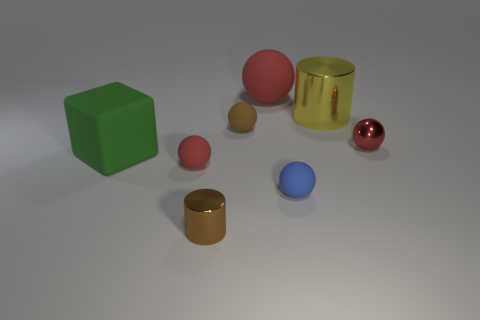Are there fewer red matte things that are on the left side of the small brown matte ball than tiny red rubber balls?
Your answer should be compact. No. There is a large red object that is made of the same material as the green cube; what shape is it?
Offer a very short reply. Sphere. What number of other things are the same shape as the brown matte thing?
Make the answer very short. 4. How many brown things are either metal cylinders or big cylinders?
Ensure brevity in your answer.  1. Is the green object the same shape as the yellow shiny thing?
Your answer should be compact. No. Is there a small metal thing that is in front of the tiny matte object behind the small red metallic ball?
Offer a very short reply. Yes. Are there an equal number of matte things that are in front of the big ball and matte spheres?
Offer a terse response. Yes. How many other objects are there of the same size as the green block?
Provide a short and direct response. 2. Are the small red thing to the left of the brown cylinder and the blue sphere that is in front of the green cube made of the same material?
Keep it short and to the point. Yes. How big is the red matte ball in front of the big thing that is on the right side of the small blue thing?
Provide a short and direct response. Small. 